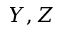Convert formula to latex. <formula><loc_0><loc_0><loc_500><loc_500>Y , Z</formula> 